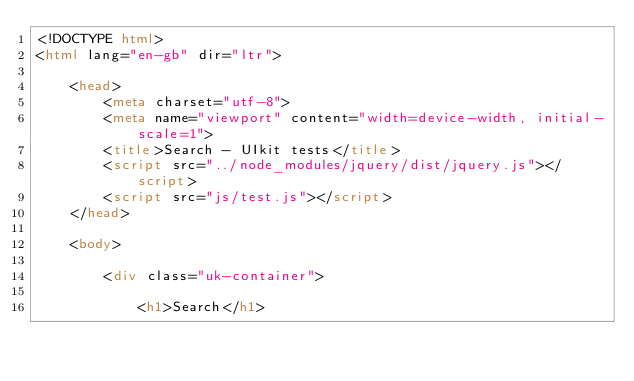Convert code to text. <code><loc_0><loc_0><loc_500><loc_500><_HTML_><!DOCTYPE html>
<html lang="en-gb" dir="ltr">

    <head>
        <meta charset="utf-8">
        <meta name="viewport" content="width=device-width, initial-scale=1">
        <title>Search - UIkit tests</title>
        <script src="../node_modules/jquery/dist/jquery.js"></script>
        <script src="js/test.js"></script>
    </head>

    <body>

        <div class="uk-container">

            <h1>Search</h1>
</code> 